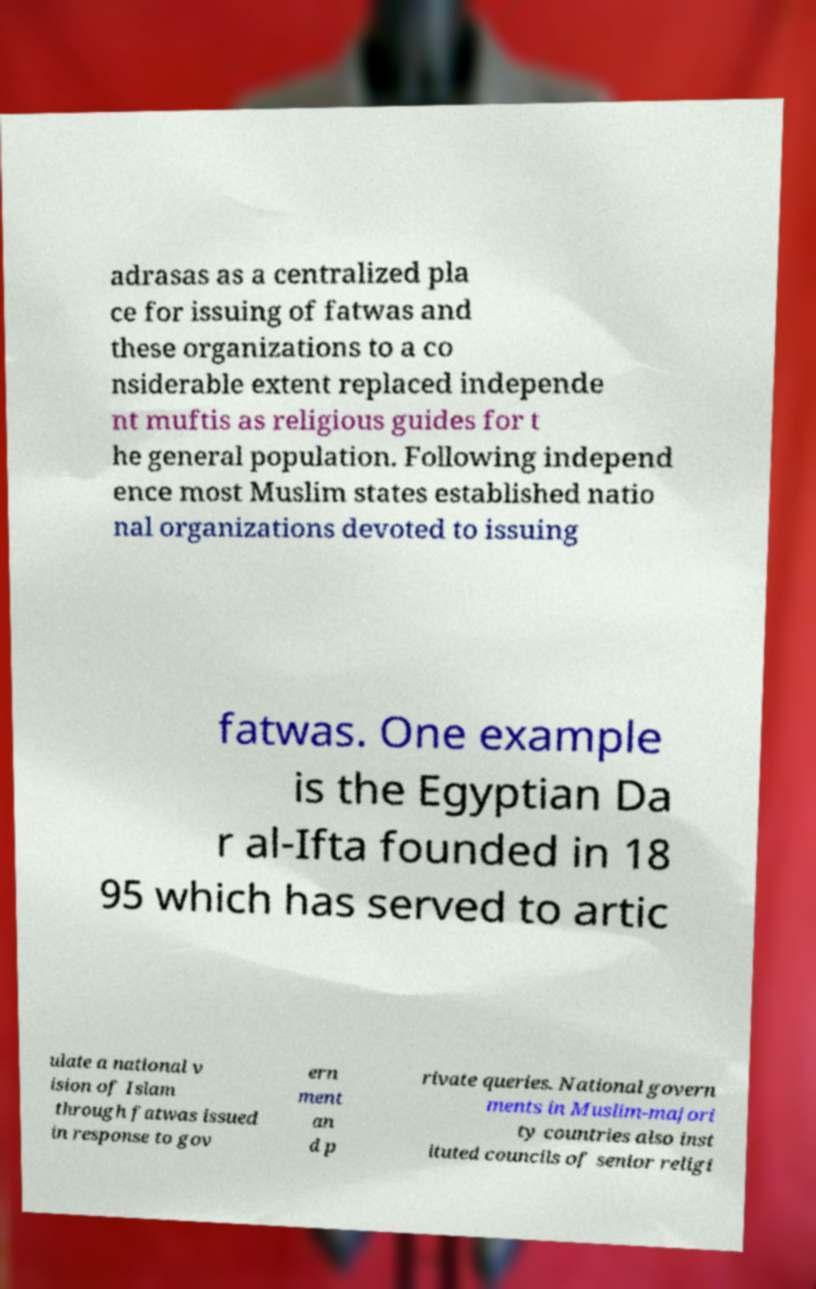Could you extract and type out the text from this image? adrasas as a centralized pla ce for issuing of fatwas and these organizations to a co nsiderable extent replaced independe nt muftis as religious guides for t he general population. Following independ ence most Muslim states established natio nal organizations devoted to issuing fatwas. One example is the Egyptian Da r al-Ifta founded in 18 95 which has served to artic ulate a national v ision of Islam through fatwas issued in response to gov ern ment an d p rivate queries. National govern ments in Muslim-majori ty countries also inst ituted councils of senior religi 